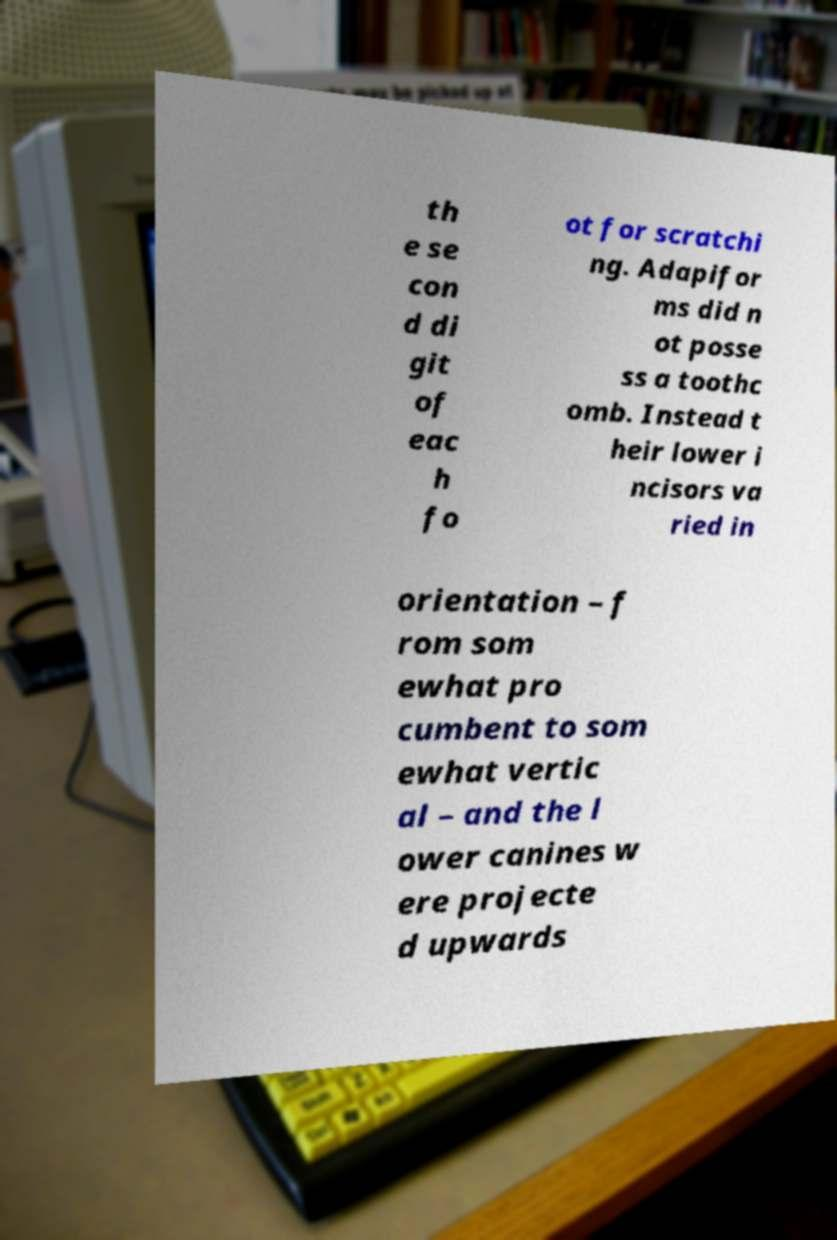Please identify and transcribe the text found in this image. th e se con d di git of eac h fo ot for scratchi ng. Adapifor ms did n ot posse ss a toothc omb. Instead t heir lower i ncisors va ried in orientation – f rom som ewhat pro cumbent to som ewhat vertic al – and the l ower canines w ere projecte d upwards 